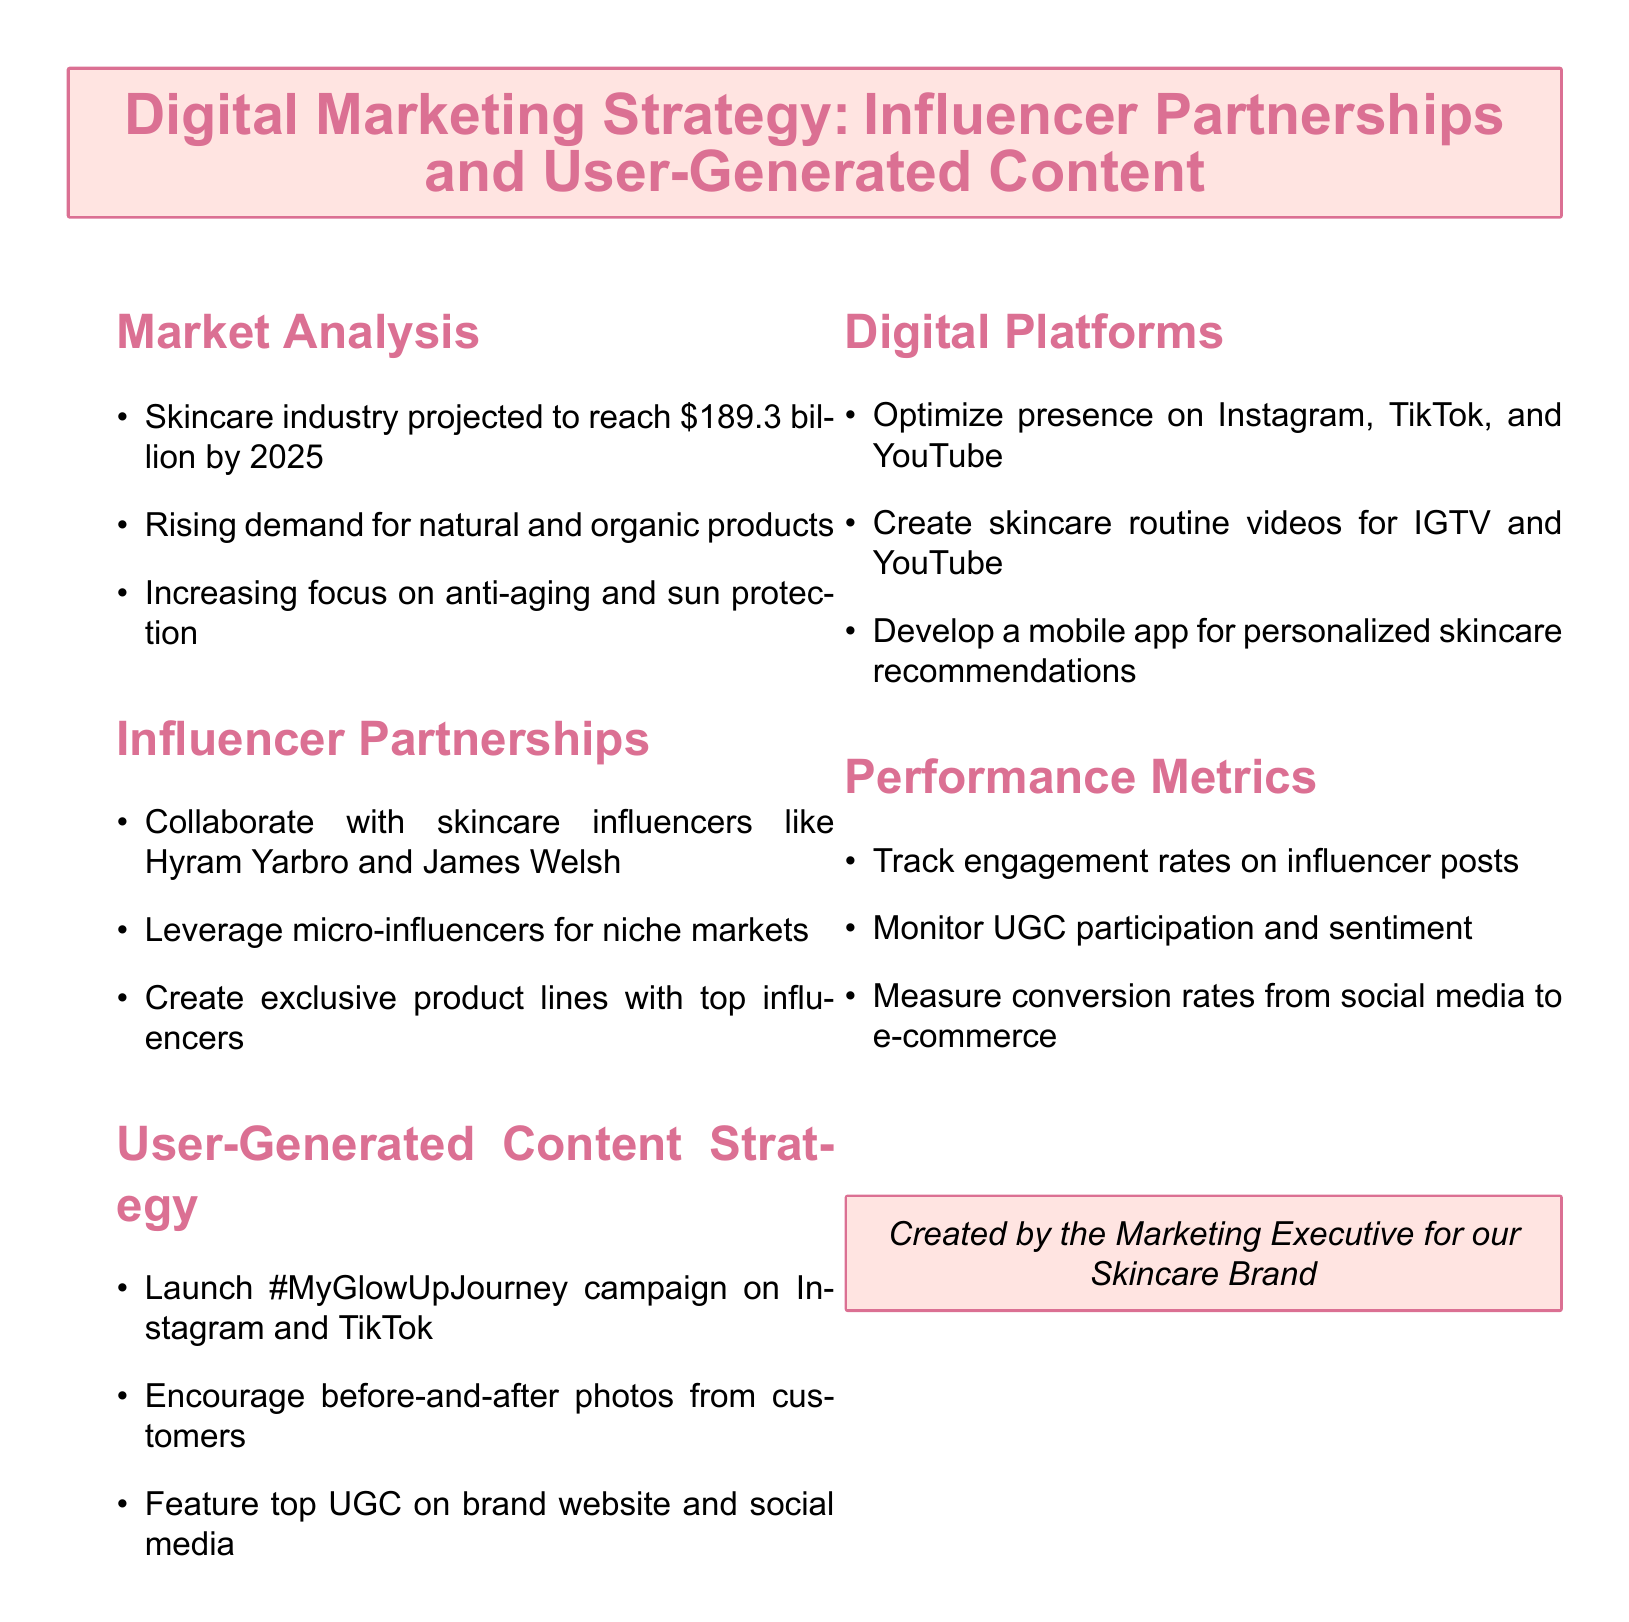What is the projected value of the skincare industry by 2025? The projected value of the skincare industry is stated in the document as $189.3 billion by 2025.
Answer: $189.3 billion Who are two skincare influencers mentioned in the document? The document lists Hyram Yarbro and James Welsh as skincare influencers for collaboration.
Answer: Hyram Yarbro and James Welsh What is the hashtag for the user-generated content campaign? The document specifies the hashtag for the user-generated content campaign as #MyGlowUpJourney.
Answer: #MyGlowUpJourney Which digital platforms does the strategy aim to optimize? The document names Instagram, TikTok, and YouTube as the digital platforms for optimization.
Answer: Instagram, TikTok, and YouTube What type of videos will be created for IGTV and YouTube? The document mentions creating skincare routine videos specifically for IGTV and YouTube.
Answer: Skincare routine videos What performance metric is used to track engagement? The document states that engagement rates on influencer posts are tracked as a performance metric.
Answer: Engagement rates on influencer posts Which type of influencers should be leveraged for niche markets? The document suggests leveraging micro-influencers specifically for niche markets.
Answer: Micro-influencers What does UGC stand for in the document? The abbreviation UGC in the document stands for User-Generated Content.
Answer: User-Generated Content 